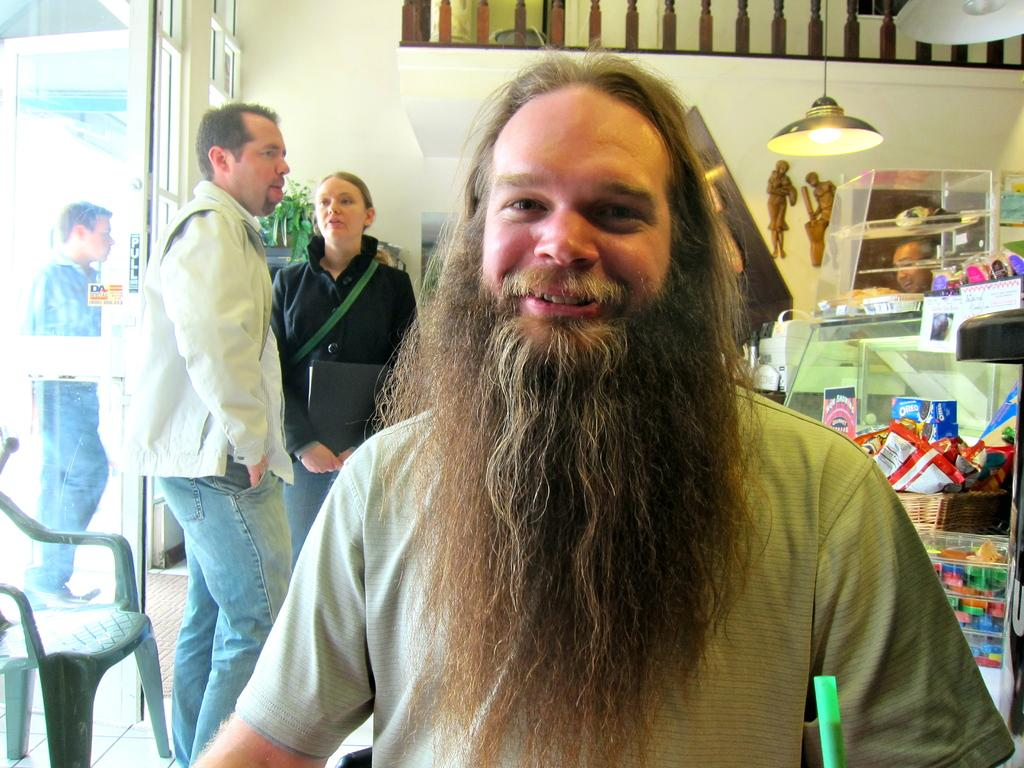Who or what is present in the image? There are people in the image. What can be seen on the left side of the image? There is a chair on the left side of the image. What is located on the right side of the image? There are objects on the right side of the image. What is visible at the top of the image? There are lights visible at the top of the image. How many rabbits can be seen flying in the image? There are no rabbits or planes visible in the image. 